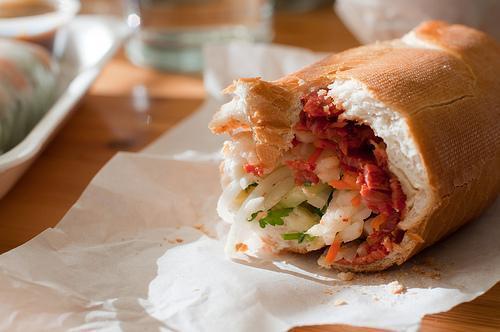How many sandwiches are there?
Give a very brief answer. 1. 